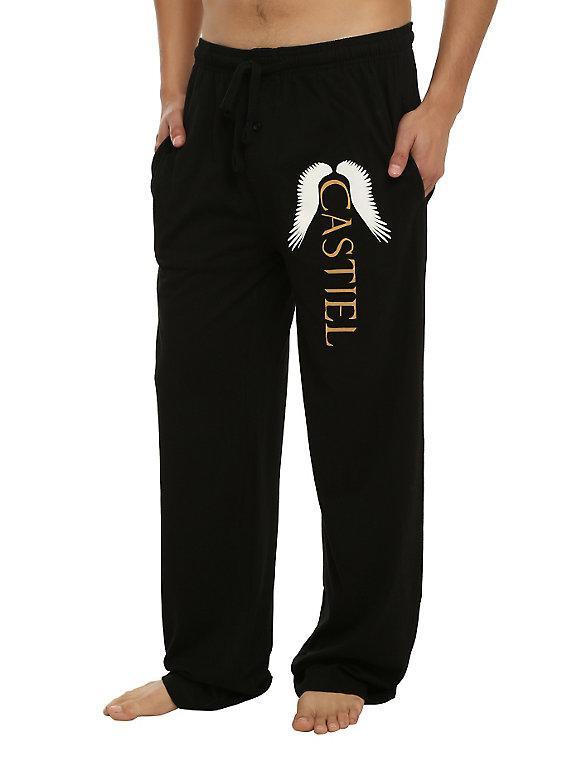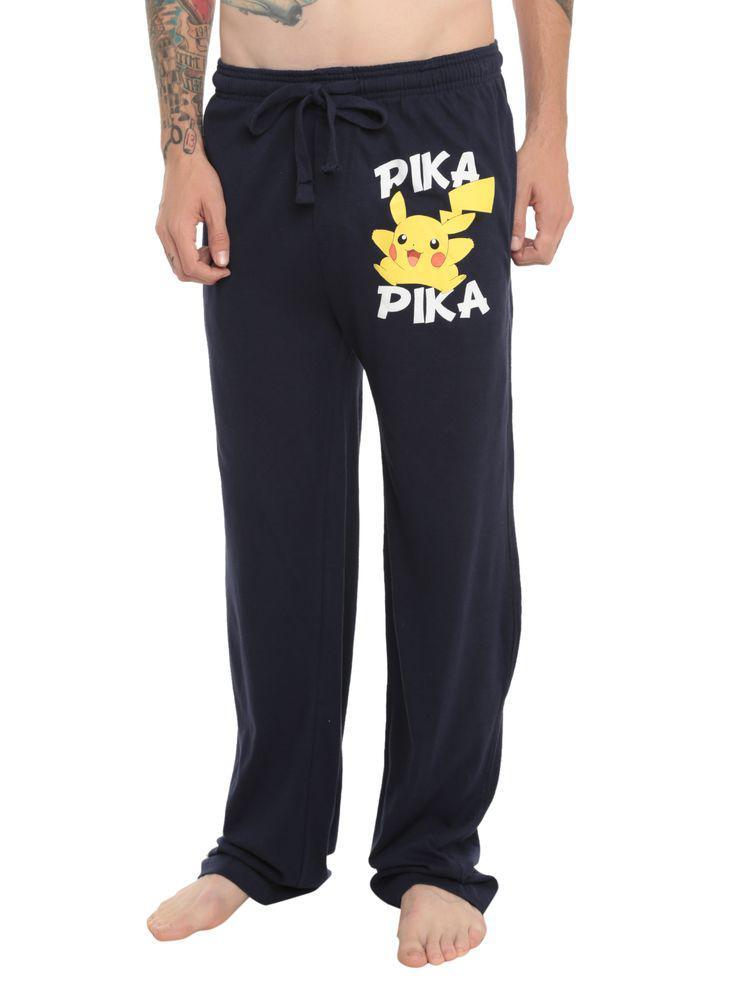The first image is the image on the left, the second image is the image on the right. Given the left and right images, does the statement "The pants do not have a repeating pattern on them." hold true? Answer yes or no. Yes. 